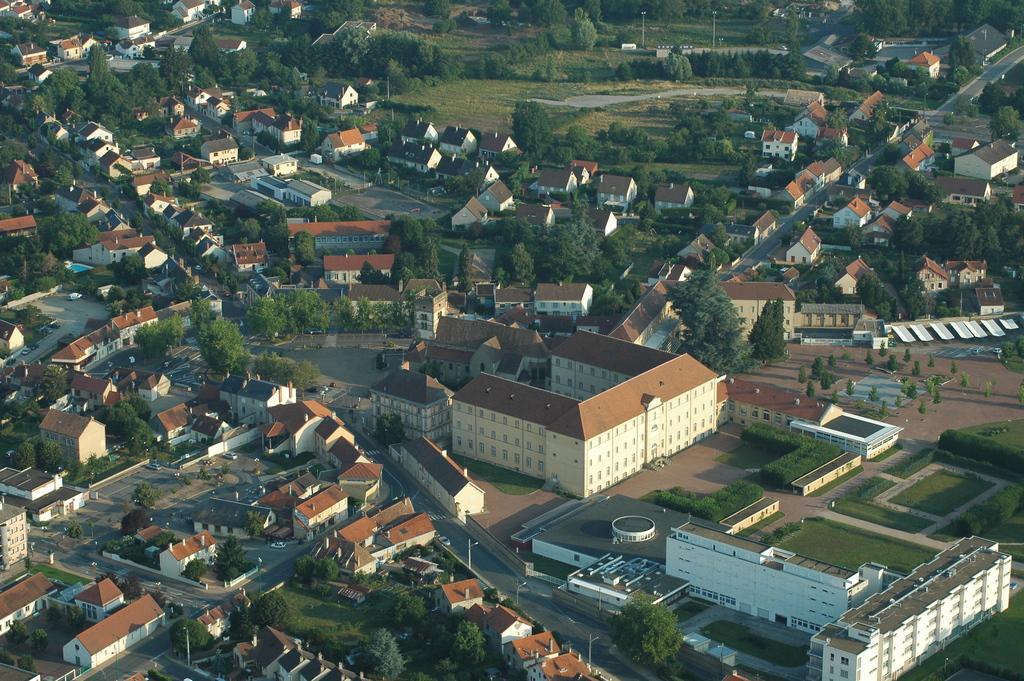What type of view is shown in the image? The image is an aerial view. What structures can be seen from this perspective? There are houses visible in the image. What natural elements are present in the image? There are trees in the image. Are there any man-made objects visible besides the houses? Yes, there are poles in the image. What type of flower is growing near the border in the image? There is no flower or border present in the image; it shows an aerial view of houses, trees, and poles. 